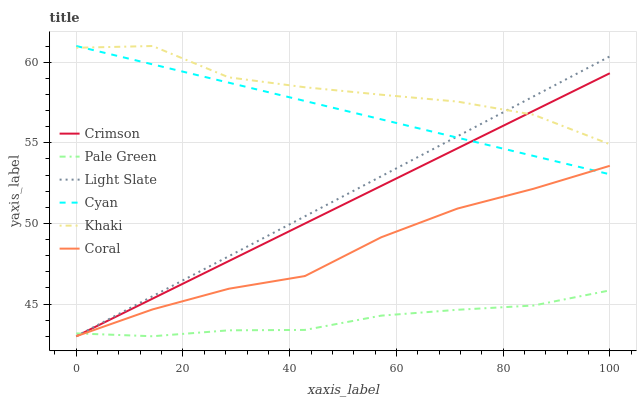Does Pale Green have the minimum area under the curve?
Answer yes or no. Yes. Does Khaki have the maximum area under the curve?
Answer yes or no. Yes. Does Light Slate have the minimum area under the curve?
Answer yes or no. No. Does Light Slate have the maximum area under the curve?
Answer yes or no. No. Is Crimson the smoothest?
Answer yes or no. Yes. Is Khaki the roughest?
Answer yes or no. Yes. Is Light Slate the smoothest?
Answer yes or no. No. Is Light Slate the roughest?
Answer yes or no. No. Does Light Slate have the lowest value?
Answer yes or no. Yes. Does Cyan have the lowest value?
Answer yes or no. No. Does Cyan have the highest value?
Answer yes or no. Yes. Does Light Slate have the highest value?
Answer yes or no. No. Is Pale Green less than Cyan?
Answer yes or no. Yes. Is Khaki greater than Coral?
Answer yes or no. Yes. Does Crimson intersect Coral?
Answer yes or no. Yes. Is Crimson less than Coral?
Answer yes or no. No. Is Crimson greater than Coral?
Answer yes or no. No. Does Pale Green intersect Cyan?
Answer yes or no. No. 